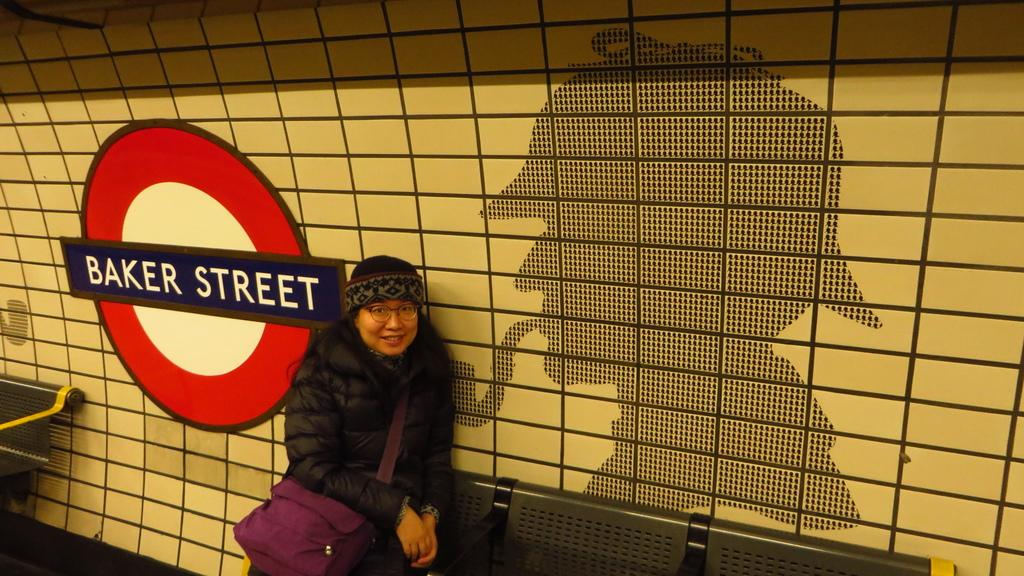Who is present in the image? There is a woman in the image. What is the woman wearing? The woman is wearing a jacket. What is the woman carrying? The woman is carrying a bag. What is the woman wearing on her face? The woman is wearing spectacles. What is the woman's facial expression? The woman is smiling. What type of wall is visible in the image? There is a tile wall in the image. What is attached to the tile wall? There is an information board on the tile wall. How does the woman sort the items in her bag in the image? There is no indication in the image that the woman is sorting items in her bag. 